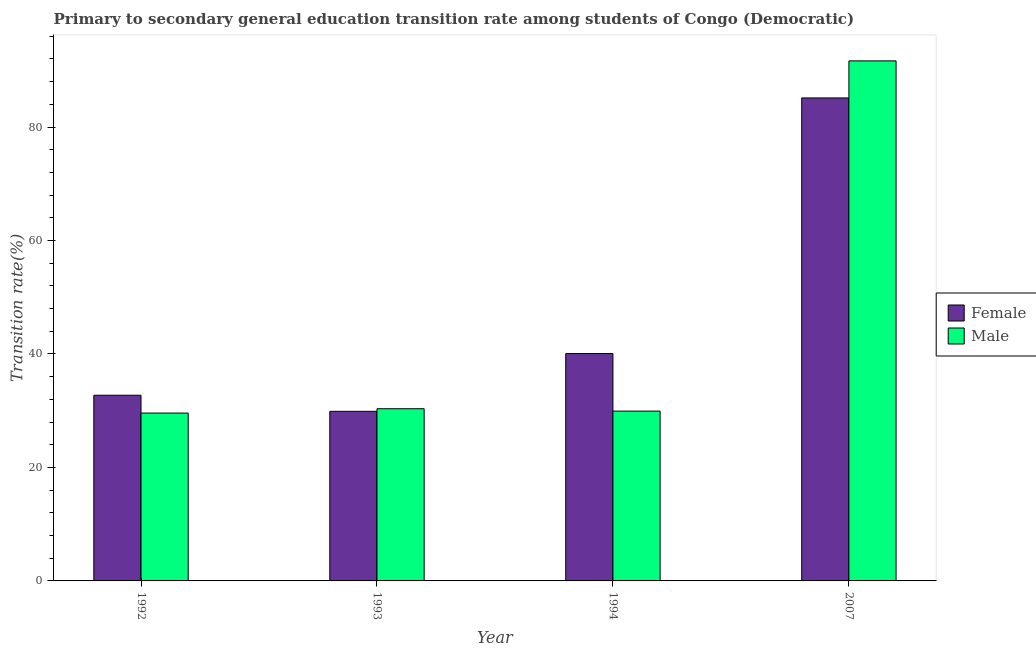Are the number of bars per tick equal to the number of legend labels?
Ensure brevity in your answer.  Yes. How many bars are there on the 1st tick from the left?
Keep it short and to the point. 2. In how many cases, is the number of bars for a given year not equal to the number of legend labels?
Your response must be concise. 0. What is the transition rate among male students in 1994?
Provide a succinct answer. 29.93. Across all years, what is the maximum transition rate among male students?
Offer a terse response. 91.66. Across all years, what is the minimum transition rate among female students?
Offer a terse response. 29.89. What is the total transition rate among male students in the graph?
Provide a succinct answer. 181.53. What is the difference between the transition rate among male students in 1994 and that in 2007?
Make the answer very short. -61.73. What is the difference between the transition rate among male students in 1992 and the transition rate among female students in 1993?
Your answer should be compact. -0.76. What is the average transition rate among female students per year?
Give a very brief answer. 46.96. In the year 2007, what is the difference between the transition rate among male students and transition rate among female students?
Provide a short and direct response. 0. In how many years, is the transition rate among female students greater than 48 %?
Give a very brief answer. 1. What is the ratio of the transition rate among male students in 1992 to that in 1993?
Your response must be concise. 0.97. Is the transition rate among male students in 1993 less than that in 1994?
Ensure brevity in your answer.  No. Is the difference between the transition rate among male students in 1993 and 1994 greater than the difference between the transition rate among female students in 1993 and 1994?
Ensure brevity in your answer.  No. What is the difference between the highest and the second highest transition rate among male students?
Give a very brief answer. 61.31. What is the difference between the highest and the lowest transition rate among female students?
Offer a very short reply. 55.24. In how many years, is the transition rate among female students greater than the average transition rate among female students taken over all years?
Your answer should be very brief. 1. Is the sum of the transition rate among male students in 1992 and 1994 greater than the maximum transition rate among female students across all years?
Offer a terse response. No. What does the 1st bar from the right in 1994 represents?
Offer a terse response. Male. How many bars are there?
Your answer should be compact. 8. Are all the bars in the graph horizontal?
Make the answer very short. No. How many years are there in the graph?
Offer a terse response. 4. Are the values on the major ticks of Y-axis written in scientific E-notation?
Make the answer very short. No. Does the graph contain grids?
Provide a short and direct response. No. Where does the legend appear in the graph?
Your answer should be compact. Center right. How are the legend labels stacked?
Your response must be concise. Vertical. What is the title of the graph?
Your answer should be very brief. Primary to secondary general education transition rate among students of Congo (Democratic). Does "Fixed telephone" appear as one of the legend labels in the graph?
Provide a succinct answer. No. What is the label or title of the Y-axis?
Your response must be concise. Transition rate(%). What is the Transition rate(%) in Female in 1992?
Offer a very short reply. 32.73. What is the Transition rate(%) of Male in 1992?
Your answer should be compact. 29.59. What is the Transition rate(%) in Female in 1993?
Offer a terse response. 29.89. What is the Transition rate(%) of Male in 1993?
Ensure brevity in your answer.  30.35. What is the Transition rate(%) in Female in 1994?
Give a very brief answer. 40.08. What is the Transition rate(%) in Male in 1994?
Provide a short and direct response. 29.93. What is the Transition rate(%) of Female in 2007?
Provide a short and direct response. 85.13. What is the Transition rate(%) of Male in 2007?
Give a very brief answer. 91.66. Across all years, what is the maximum Transition rate(%) of Female?
Ensure brevity in your answer.  85.13. Across all years, what is the maximum Transition rate(%) in Male?
Provide a succinct answer. 91.66. Across all years, what is the minimum Transition rate(%) in Female?
Give a very brief answer. 29.89. Across all years, what is the minimum Transition rate(%) in Male?
Give a very brief answer. 29.59. What is the total Transition rate(%) of Female in the graph?
Make the answer very short. 187.83. What is the total Transition rate(%) of Male in the graph?
Keep it short and to the point. 181.53. What is the difference between the Transition rate(%) of Female in 1992 and that in 1993?
Your answer should be compact. 2.84. What is the difference between the Transition rate(%) in Male in 1992 and that in 1993?
Your answer should be compact. -0.76. What is the difference between the Transition rate(%) in Female in 1992 and that in 1994?
Make the answer very short. -7.34. What is the difference between the Transition rate(%) in Male in 1992 and that in 1994?
Ensure brevity in your answer.  -0.35. What is the difference between the Transition rate(%) in Female in 1992 and that in 2007?
Provide a short and direct response. -52.4. What is the difference between the Transition rate(%) in Male in 1992 and that in 2007?
Offer a terse response. -62.08. What is the difference between the Transition rate(%) in Female in 1993 and that in 1994?
Provide a short and direct response. -10.18. What is the difference between the Transition rate(%) in Male in 1993 and that in 1994?
Ensure brevity in your answer.  0.42. What is the difference between the Transition rate(%) of Female in 1993 and that in 2007?
Provide a short and direct response. -55.24. What is the difference between the Transition rate(%) of Male in 1993 and that in 2007?
Your answer should be very brief. -61.31. What is the difference between the Transition rate(%) in Female in 1994 and that in 2007?
Your answer should be compact. -45.05. What is the difference between the Transition rate(%) of Male in 1994 and that in 2007?
Keep it short and to the point. -61.73. What is the difference between the Transition rate(%) in Female in 1992 and the Transition rate(%) in Male in 1993?
Make the answer very short. 2.38. What is the difference between the Transition rate(%) in Female in 1992 and the Transition rate(%) in Male in 1994?
Give a very brief answer. 2.8. What is the difference between the Transition rate(%) in Female in 1992 and the Transition rate(%) in Male in 2007?
Offer a terse response. -58.93. What is the difference between the Transition rate(%) of Female in 1993 and the Transition rate(%) of Male in 1994?
Provide a short and direct response. -0.04. What is the difference between the Transition rate(%) of Female in 1993 and the Transition rate(%) of Male in 2007?
Offer a very short reply. -61.77. What is the difference between the Transition rate(%) in Female in 1994 and the Transition rate(%) in Male in 2007?
Offer a very short reply. -51.59. What is the average Transition rate(%) in Female per year?
Offer a terse response. 46.96. What is the average Transition rate(%) in Male per year?
Your answer should be very brief. 45.38. In the year 1992, what is the difference between the Transition rate(%) of Female and Transition rate(%) of Male?
Offer a terse response. 3.14. In the year 1993, what is the difference between the Transition rate(%) in Female and Transition rate(%) in Male?
Provide a short and direct response. -0.46. In the year 1994, what is the difference between the Transition rate(%) in Female and Transition rate(%) in Male?
Your answer should be very brief. 10.14. In the year 2007, what is the difference between the Transition rate(%) in Female and Transition rate(%) in Male?
Keep it short and to the point. -6.53. What is the ratio of the Transition rate(%) in Female in 1992 to that in 1993?
Your answer should be very brief. 1.09. What is the ratio of the Transition rate(%) of Male in 1992 to that in 1993?
Make the answer very short. 0.97. What is the ratio of the Transition rate(%) of Female in 1992 to that in 1994?
Your answer should be very brief. 0.82. What is the ratio of the Transition rate(%) of Male in 1992 to that in 1994?
Ensure brevity in your answer.  0.99. What is the ratio of the Transition rate(%) of Female in 1992 to that in 2007?
Give a very brief answer. 0.38. What is the ratio of the Transition rate(%) in Male in 1992 to that in 2007?
Give a very brief answer. 0.32. What is the ratio of the Transition rate(%) in Female in 1993 to that in 1994?
Offer a terse response. 0.75. What is the ratio of the Transition rate(%) in Female in 1993 to that in 2007?
Give a very brief answer. 0.35. What is the ratio of the Transition rate(%) of Male in 1993 to that in 2007?
Provide a succinct answer. 0.33. What is the ratio of the Transition rate(%) of Female in 1994 to that in 2007?
Your response must be concise. 0.47. What is the ratio of the Transition rate(%) of Male in 1994 to that in 2007?
Provide a succinct answer. 0.33. What is the difference between the highest and the second highest Transition rate(%) of Female?
Give a very brief answer. 45.05. What is the difference between the highest and the second highest Transition rate(%) of Male?
Offer a very short reply. 61.31. What is the difference between the highest and the lowest Transition rate(%) in Female?
Offer a terse response. 55.24. What is the difference between the highest and the lowest Transition rate(%) in Male?
Keep it short and to the point. 62.08. 